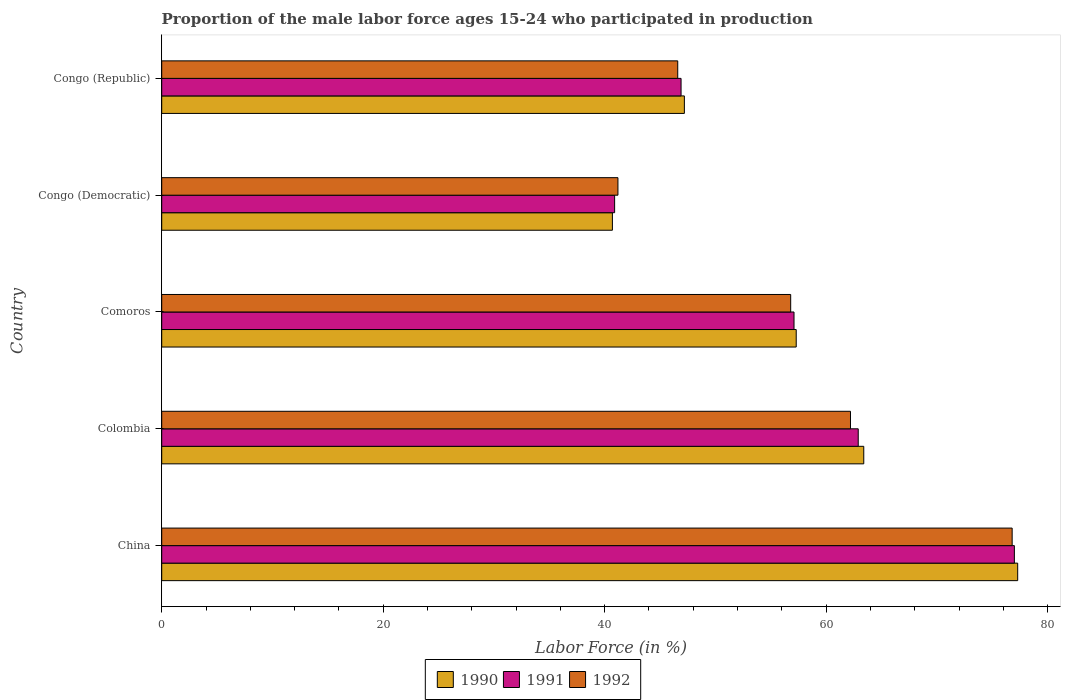How many groups of bars are there?
Offer a very short reply. 5. How many bars are there on the 4th tick from the top?
Give a very brief answer. 3. What is the label of the 1st group of bars from the top?
Ensure brevity in your answer.  Congo (Republic). What is the proportion of the male labor force who participated in production in 1992 in China?
Your answer should be very brief. 76.8. Across all countries, what is the maximum proportion of the male labor force who participated in production in 1992?
Provide a short and direct response. 76.8. Across all countries, what is the minimum proportion of the male labor force who participated in production in 1992?
Your response must be concise. 41.2. In which country was the proportion of the male labor force who participated in production in 1991 minimum?
Your answer should be very brief. Congo (Democratic). What is the total proportion of the male labor force who participated in production in 1991 in the graph?
Keep it short and to the point. 284.8. What is the difference between the proportion of the male labor force who participated in production in 1991 in Colombia and that in Congo (Democratic)?
Provide a short and direct response. 22. What is the difference between the proportion of the male labor force who participated in production in 1991 in China and the proportion of the male labor force who participated in production in 1990 in Congo (Republic)?
Keep it short and to the point. 29.8. What is the average proportion of the male labor force who participated in production in 1991 per country?
Your answer should be very brief. 56.96. What is the difference between the proportion of the male labor force who participated in production in 1991 and proportion of the male labor force who participated in production in 1990 in Comoros?
Ensure brevity in your answer.  -0.2. What is the ratio of the proportion of the male labor force who participated in production in 1990 in Colombia to that in Congo (Democratic)?
Ensure brevity in your answer.  1.56. Is the proportion of the male labor force who participated in production in 1992 in Colombia less than that in Congo (Republic)?
Ensure brevity in your answer.  No. What is the difference between the highest and the second highest proportion of the male labor force who participated in production in 1990?
Provide a succinct answer. 13.9. What is the difference between the highest and the lowest proportion of the male labor force who participated in production in 1992?
Your answer should be very brief. 35.6. In how many countries, is the proportion of the male labor force who participated in production in 1990 greater than the average proportion of the male labor force who participated in production in 1990 taken over all countries?
Keep it short and to the point. 3. Is the sum of the proportion of the male labor force who participated in production in 1991 in China and Colombia greater than the maximum proportion of the male labor force who participated in production in 1992 across all countries?
Your answer should be very brief. Yes. Are all the bars in the graph horizontal?
Offer a very short reply. Yes. What is the difference between two consecutive major ticks on the X-axis?
Your response must be concise. 20. Where does the legend appear in the graph?
Your answer should be very brief. Bottom center. How are the legend labels stacked?
Your answer should be compact. Horizontal. What is the title of the graph?
Provide a succinct answer. Proportion of the male labor force ages 15-24 who participated in production. What is the label or title of the Y-axis?
Your answer should be compact. Country. What is the Labor Force (in %) in 1990 in China?
Offer a very short reply. 77.3. What is the Labor Force (in %) of 1991 in China?
Your response must be concise. 77. What is the Labor Force (in %) of 1992 in China?
Your response must be concise. 76.8. What is the Labor Force (in %) in 1990 in Colombia?
Ensure brevity in your answer.  63.4. What is the Labor Force (in %) in 1991 in Colombia?
Your response must be concise. 62.9. What is the Labor Force (in %) of 1992 in Colombia?
Make the answer very short. 62.2. What is the Labor Force (in %) of 1990 in Comoros?
Keep it short and to the point. 57.3. What is the Labor Force (in %) of 1991 in Comoros?
Provide a succinct answer. 57.1. What is the Labor Force (in %) in 1992 in Comoros?
Provide a short and direct response. 56.8. What is the Labor Force (in %) in 1990 in Congo (Democratic)?
Provide a short and direct response. 40.7. What is the Labor Force (in %) of 1991 in Congo (Democratic)?
Offer a very short reply. 40.9. What is the Labor Force (in %) in 1992 in Congo (Democratic)?
Provide a succinct answer. 41.2. What is the Labor Force (in %) in 1990 in Congo (Republic)?
Your answer should be compact. 47.2. What is the Labor Force (in %) of 1991 in Congo (Republic)?
Offer a very short reply. 46.9. What is the Labor Force (in %) of 1992 in Congo (Republic)?
Give a very brief answer. 46.6. Across all countries, what is the maximum Labor Force (in %) of 1990?
Provide a short and direct response. 77.3. Across all countries, what is the maximum Labor Force (in %) of 1991?
Offer a terse response. 77. Across all countries, what is the maximum Labor Force (in %) of 1992?
Offer a very short reply. 76.8. Across all countries, what is the minimum Labor Force (in %) of 1990?
Your answer should be compact. 40.7. Across all countries, what is the minimum Labor Force (in %) in 1991?
Your answer should be compact. 40.9. Across all countries, what is the minimum Labor Force (in %) of 1992?
Offer a terse response. 41.2. What is the total Labor Force (in %) in 1990 in the graph?
Offer a very short reply. 285.9. What is the total Labor Force (in %) of 1991 in the graph?
Make the answer very short. 284.8. What is the total Labor Force (in %) of 1992 in the graph?
Ensure brevity in your answer.  283.6. What is the difference between the Labor Force (in %) of 1990 in China and that in Colombia?
Make the answer very short. 13.9. What is the difference between the Labor Force (in %) of 1991 in China and that in Comoros?
Make the answer very short. 19.9. What is the difference between the Labor Force (in %) of 1990 in China and that in Congo (Democratic)?
Keep it short and to the point. 36.6. What is the difference between the Labor Force (in %) in 1991 in China and that in Congo (Democratic)?
Keep it short and to the point. 36.1. What is the difference between the Labor Force (in %) in 1992 in China and that in Congo (Democratic)?
Your answer should be very brief. 35.6. What is the difference between the Labor Force (in %) of 1990 in China and that in Congo (Republic)?
Your response must be concise. 30.1. What is the difference between the Labor Force (in %) in 1991 in China and that in Congo (Republic)?
Ensure brevity in your answer.  30.1. What is the difference between the Labor Force (in %) of 1992 in China and that in Congo (Republic)?
Ensure brevity in your answer.  30.2. What is the difference between the Labor Force (in %) in 1990 in Colombia and that in Comoros?
Offer a very short reply. 6.1. What is the difference between the Labor Force (in %) of 1991 in Colombia and that in Comoros?
Keep it short and to the point. 5.8. What is the difference between the Labor Force (in %) in 1990 in Colombia and that in Congo (Democratic)?
Give a very brief answer. 22.7. What is the difference between the Labor Force (in %) of 1992 in Colombia and that in Congo (Democratic)?
Your response must be concise. 21. What is the difference between the Labor Force (in %) in 1990 in Colombia and that in Congo (Republic)?
Ensure brevity in your answer.  16.2. What is the difference between the Labor Force (in %) in 1992 in Colombia and that in Congo (Republic)?
Your answer should be very brief. 15.6. What is the difference between the Labor Force (in %) in 1990 in Comoros and that in Congo (Democratic)?
Keep it short and to the point. 16.6. What is the difference between the Labor Force (in %) of 1991 in Comoros and that in Congo (Democratic)?
Your response must be concise. 16.2. What is the difference between the Labor Force (in %) of 1990 in Comoros and that in Congo (Republic)?
Offer a terse response. 10.1. What is the difference between the Labor Force (in %) of 1991 in Comoros and that in Congo (Republic)?
Provide a succinct answer. 10.2. What is the difference between the Labor Force (in %) of 1992 in Comoros and that in Congo (Republic)?
Ensure brevity in your answer.  10.2. What is the difference between the Labor Force (in %) in 1992 in Congo (Democratic) and that in Congo (Republic)?
Ensure brevity in your answer.  -5.4. What is the difference between the Labor Force (in %) in 1990 in China and the Labor Force (in %) in 1992 in Colombia?
Ensure brevity in your answer.  15.1. What is the difference between the Labor Force (in %) of 1990 in China and the Labor Force (in %) of 1991 in Comoros?
Keep it short and to the point. 20.2. What is the difference between the Labor Force (in %) in 1991 in China and the Labor Force (in %) in 1992 in Comoros?
Your response must be concise. 20.2. What is the difference between the Labor Force (in %) in 1990 in China and the Labor Force (in %) in 1991 in Congo (Democratic)?
Your response must be concise. 36.4. What is the difference between the Labor Force (in %) of 1990 in China and the Labor Force (in %) of 1992 in Congo (Democratic)?
Your answer should be compact. 36.1. What is the difference between the Labor Force (in %) in 1991 in China and the Labor Force (in %) in 1992 in Congo (Democratic)?
Keep it short and to the point. 35.8. What is the difference between the Labor Force (in %) of 1990 in China and the Labor Force (in %) of 1991 in Congo (Republic)?
Your answer should be very brief. 30.4. What is the difference between the Labor Force (in %) of 1990 in China and the Labor Force (in %) of 1992 in Congo (Republic)?
Offer a terse response. 30.7. What is the difference between the Labor Force (in %) of 1991 in China and the Labor Force (in %) of 1992 in Congo (Republic)?
Give a very brief answer. 30.4. What is the difference between the Labor Force (in %) of 1990 in Colombia and the Labor Force (in %) of 1992 in Comoros?
Your answer should be very brief. 6.6. What is the difference between the Labor Force (in %) in 1990 in Colombia and the Labor Force (in %) in 1991 in Congo (Democratic)?
Make the answer very short. 22.5. What is the difference between the Labor Force (in %) in 1990 in Colombia and the Labor Force (in %) in 1992 in Congo (Democratic)?
Your answer should be very brief. 22.2. What is the difference between the Labor Force (in %) of 1991 in Colombia and the Labor Force (in %) of 1992 in Congo (Democratic)?
Make the answer very short. 21.7. What is the difference between the Labor Force (in %) of 1990 in Colombia and the Labor Force (in %) of 1992 in Congo (Republic)?
Give a very brief answer. 16.8. What is the difference between the Labor Force (in %) of 1990 in Comoros and the Labor Force (in %) of 1991 in Congo (Democratic)?
Provide a short and direct response. 16.4. What is the difference between the Labor Force (in %) in 1990 in Comoros and the Labor Force (in %) in 1992 in Congo (Democratic)?
Offer a terse response. 16.1. What is the difference between the Labor Force (in %) in 1991 in Comoros and the Labor Force (in %) in 1992 in Congo (Democratic)?
Your answer should be compact. 15.9. What is the difference between the Labor Force (in %) in 1991 in Comoros and the Labor Force (in %) in 1992 in Congo (Republic)?
Offer a terse response. 10.5. What is the difference between the Labor Force (in %) of 1990 in Congo (Democratic) and the Labor Force (in %) of 1991 in Congo (Republic)?
Your answer should be compact. -6.2. What is the difference between the Labor Force (in %) in 1991 in Congo (Democratic) and the Labor Force (in %) in 1992 in Congo (Republic)?
Provide a succinct answer. -5.7. What is the average Labor Force (in %) of 1990 per country?
Provide a short and direct response. 57.18. What is the average Labor Force (in %) of 1991 per country?
Your answer should be very brief. 56.96. What is the average Labor Force (in %) in 1992 per country?
Make the answer very short. 56.72. What is the difference between the Labor Force (in %) in 1990 and Labor Force (in %) in 1991 in China?
Your answer should be compact. 0.3. What is the difference between the Labor Force (in %) in 1990 and Labor Force (in %) in 1992 in China?
Ensure brevity in your answer.  0.5. What is the difference between the Labor Force (in %) of 1991 and Labor Force (in %) of 1992 in China?
Offer a very short reply. 0.2. What is the difference between the Labor Force (in %) in 1990 and Labor Force (in %) in 1992 in Colombia?
Your answer should be very brief. 1.2. What is the difference between the Labor Force (in %) of 1991 and Labor Force (in %) of 1992 in Comoros?
Your answer should be very brief. 0.3. What is the difference between the Labor Force (in %) of 1990 and Labor Force (in %) of 1991 in Congo (Democratic)?
Provide a short and direct response. -0.2. What is the difference between the Labor Force (in %) of 1990 and Labor Force (in %) of 1992 in Congo (Democratic)?
Keep it short and to the point. -0.5. What is the difference between the Labor Force (in %) in 1991 and Labor Force (in %) in 1992 in Congo (Democratic)?
Provide a short and direct response. -0.3. What is the difference between the Labor Force (in %) of 1990 and Labor Force (in %) of 1991 in Congo (Republic)?
Keep it short and to the point. 0.3. What is the difference between the Labor Force (in %) of 1991 and Labor Force (in %) of 1992 in Congo (Republic)?
Your response must be concise. 0.3. What is the ratio of the Labor Force (in %) in 1990 in China to that in Colombia?
Make the answer very short. 1.22. What is the ratio of the Labor Force (in %) in 1991 in China to that in Colombia?
Keep it short and to the point. 1.22. What is the ratio of the Labor Force (in %) of 1992 in China to that in Colombia?
Give a very brief answer. 1.23. What is the ratio of the Labor Force (in %) in 1990 in China to that in Comoros?
Your answer should be compact. 1.35. What is the ratio of the Labor Force (in %) of 1991 in China to that in Comoros?
Provide a short and direct response. 1.35. What is the ratio of the Labor Force (in %) of 1992 in China to that in Comoros?
Ensure brevity in your answer.  1.35. What is the ratio of the Labor Force (in %) in 1990 in China to that in Congo (Democratic)?
Keep it short and to the point. 1.9. What is the ratio of the Labor Force (in %) of 1991 in China to that in Congo (Democratic)?
Give a very brief answer. 1.88. What is the ratio of the Labor Force (in %) of 1992 in China to that in Congo (Democratic)?
Your answer should be very brief. 1.86. What is the ratio of the Labor Force (in %) of 1990 in China to that in Congo (Republic)?
Give a very brief answer. 1.64. What is the ratio of the Labor Force (in %) of 1991 in China to that in Congo (Republic)?
Give a very brief answer. 1.64. What is the ratio of the Labor Force (in %) of 1992 in China to that in Congo (Republic)?
Offer a very short reply. 1.65. What is the ratio of the Labor Force (in %) of 1990 in Colombia to that in Comoros?
Offer a terse response. 1.11. What is the ratio of the Labor Force (in %) in 1991 in Colombia to that in Comoros?
Offer a very short reply. 1.1. What is the ratio of the Labor Force (in %) of 1992 in Colombia to that in Comoros?
Your response must be concise. 1.1. What is the ratio of the Labor Force (in %) in 1990 in Colombia to that in Congo (Democratic)?
Your answer should be very brief. 1.56. What is the ratio of the Labor Force (in %) of 1991 in Colombia to that in Congo (Democratic)?
Provide a short and direct response. 1.54. What is the ratio of the Labor Force (in %) in 1992 in Colombia to that in Congo (Democratic)?
Your answer should be compact. 1.51. What is the ratio of the Labor Force (in %) of 1990 in Colombia to that in Congo (Republic)?
Ensure brevity in your answer.  1.34. What is the ratio of the Labor Force (in %) in 1991 in Colombia to that in Congo (Republic)?
Keep it short and to the point. 1.34. What is the ratio of the Labor Force (in %) in 1992 in Colombia to that in Congo (Republic)?
Ensure brevity in your answer.  1.33. What is the ratio of the Labor Force (in %) in 1990 in Comoros to that in Congo (Democratic)?
Your response must be concise. 1.41. What is the ratio of the Labor Force (in %) of 1991 in Comoros to that in Congo (Democratic)?
Your answer should be compact. 1.4. What is the ratio of the Labor Force (in %) in 1992 in Comoros to that in Congo (Democratic)?
Provide a succinct answer. 1.38. What is the ratio of the Labor Force (in %) in 1990 in Comoros to that in Congo (Republic)?
Provide a short and direct response. 1.21. What is the ratio of the Labor Force (in %) of 1991 in Comoros to that in Congo (Republic)?
Make the answer very short. 1.22. What is the ratio of the Labor Force (in %) in 1992 in Comoros to that in Congo (Republic)?
Keep it short and to the point. 1.22. What is the ratio of the Labor Force (in %) in 1990 in Congo (Democratic) to that in Congo (Republic)?
Your answer should be very brief. 0.86. What is the ratio of the Labor Force (in %) of 1991 in Congo (Democratic) to that in Congo (Republic)?
Your answer should be very brief. 0.87. What is the ratio of the Labor Force (in %) in 1992 in Congo (Democratic) to that in Congo (Republic)?
Provide a succinct answer. 0.88. What is the difference between the highest and the lowest Labor Force (in %) of 1990?
Your response must be concise. 36.6. What is the difference between the highest and the lowest Labor Force (in %) of 1991?
Keep it short and to the point. 36.1. What is the difference between the highest and the lowest Labor Force (in %) in 1992?
Make the answer very short. 35.6. 